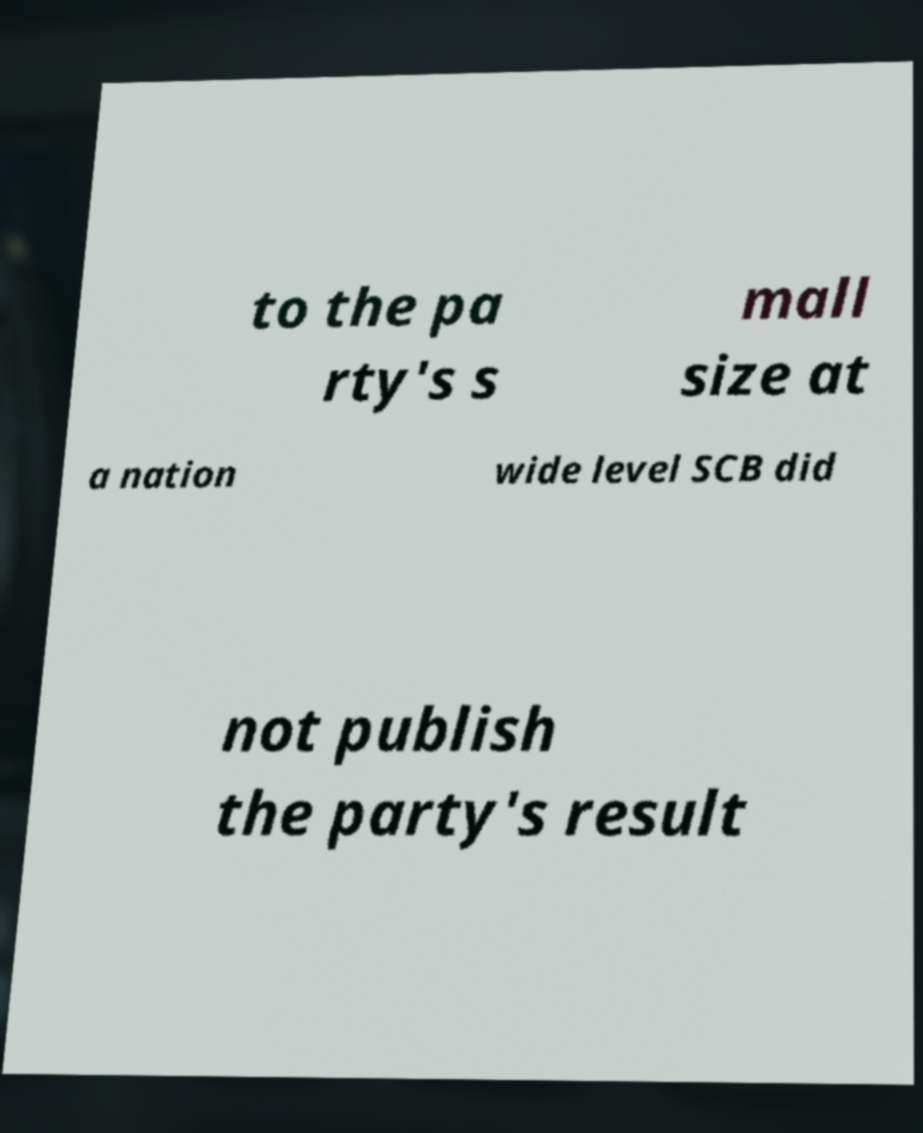Could you assist in decoding the text presented in this image and type it out clearly? to the pa rty's s mall size at a nation wide level SCB did not publish the party's result 